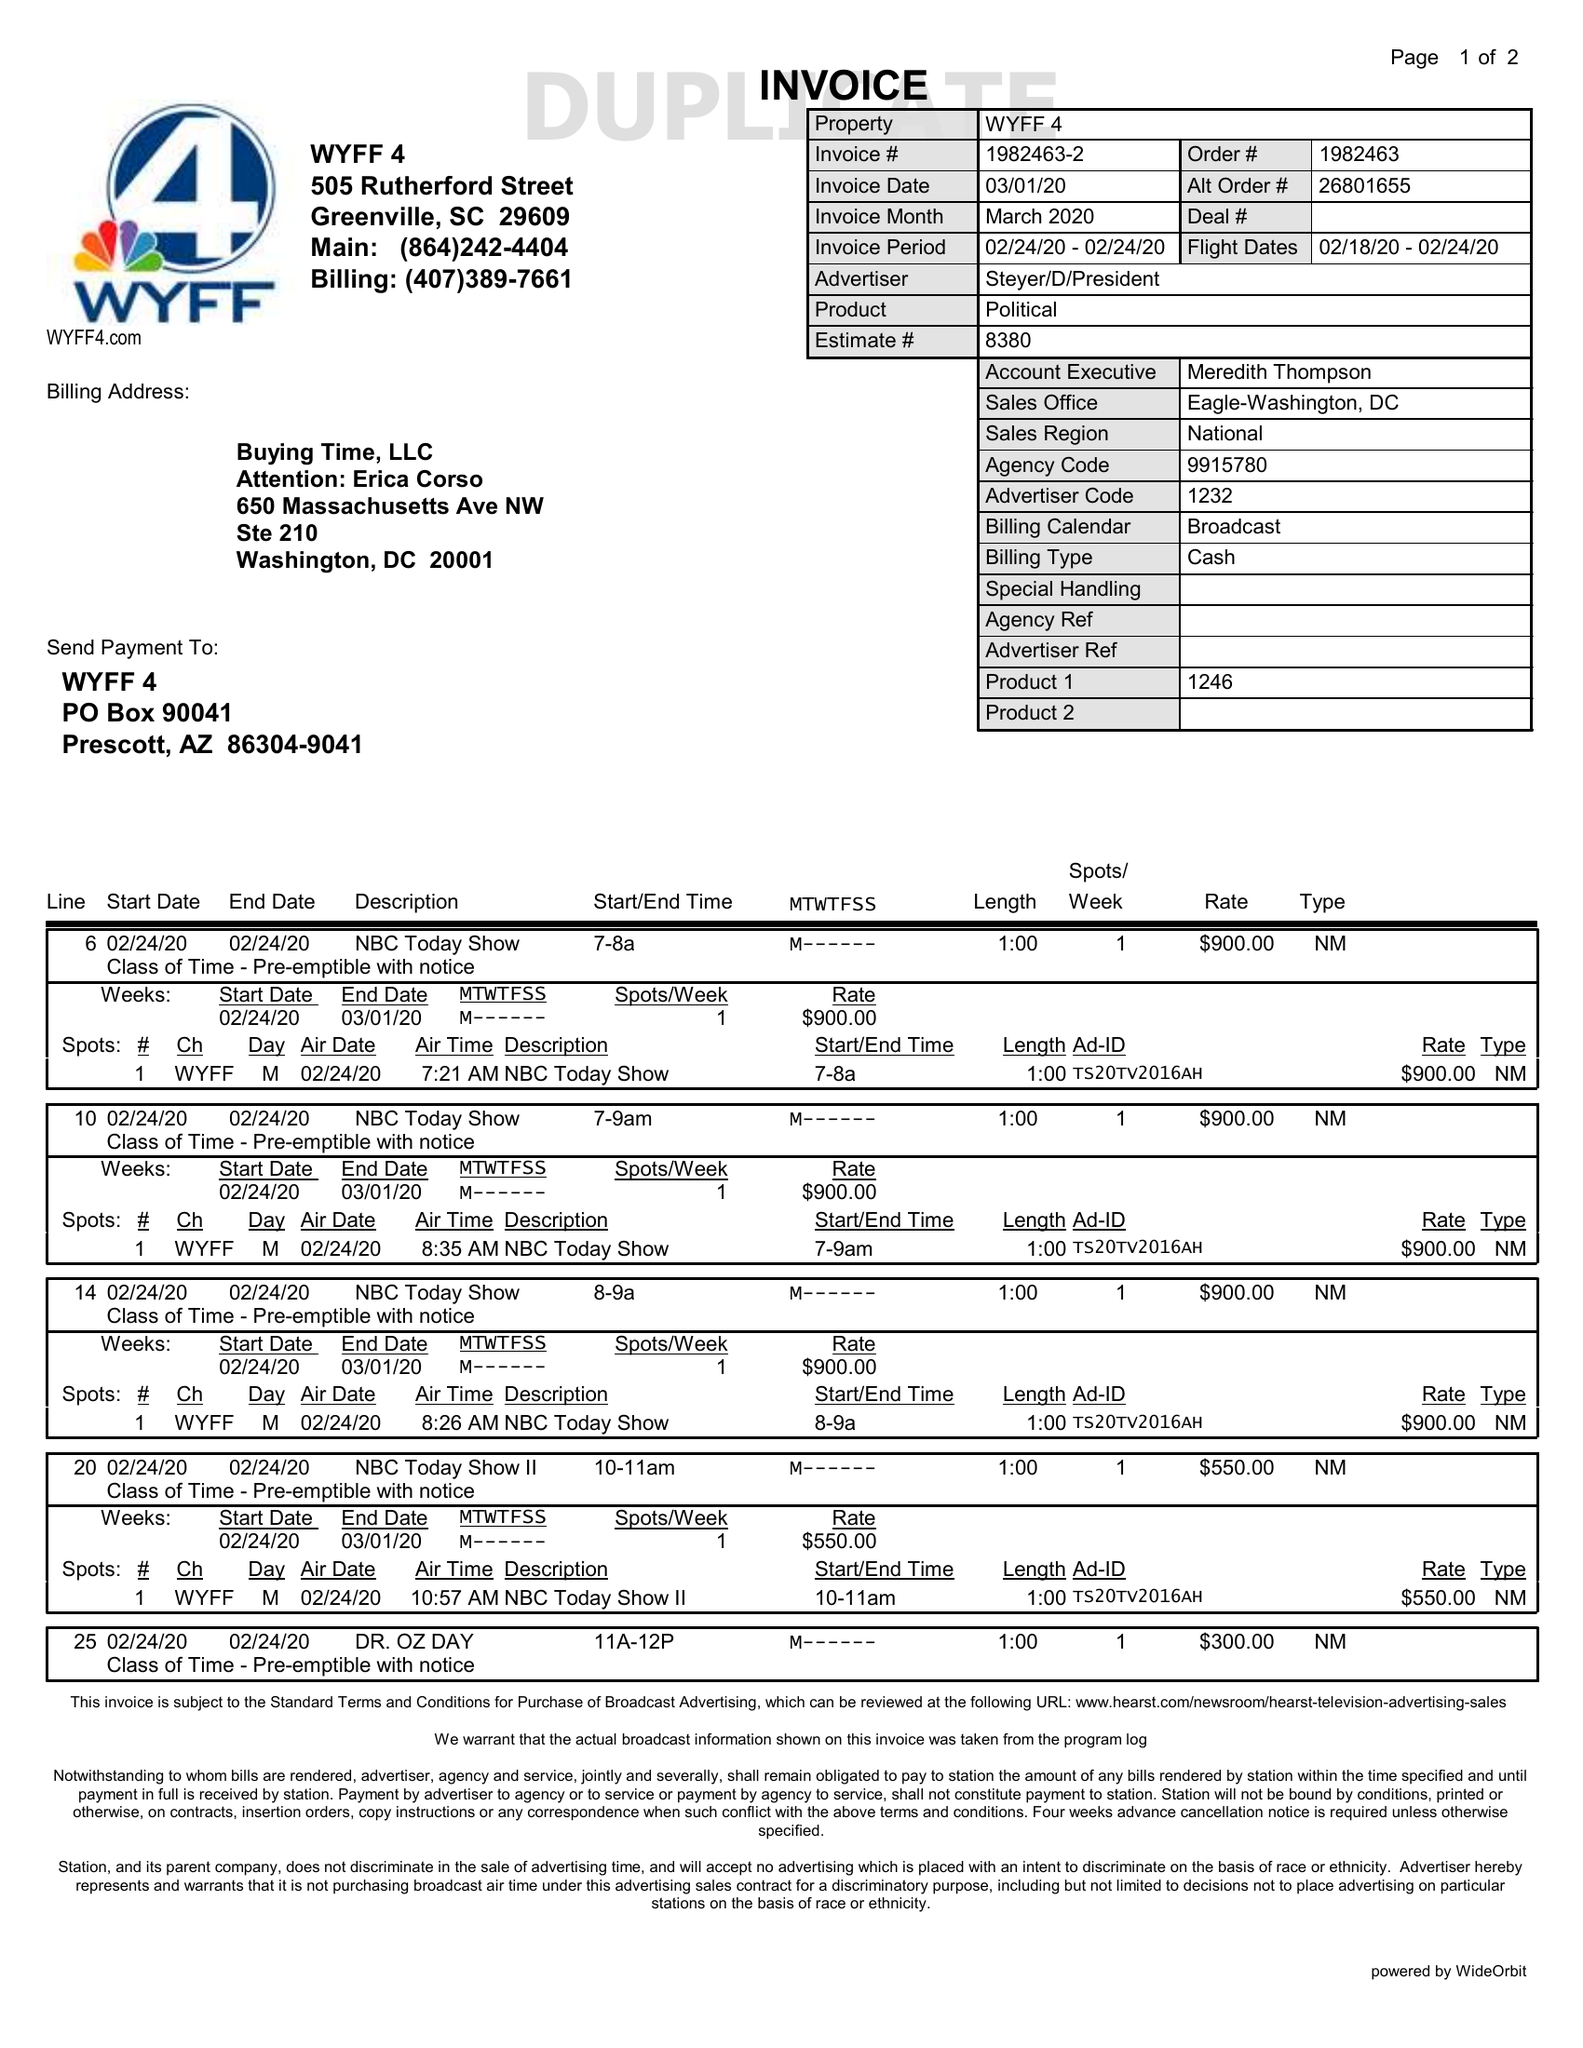What is the value for the advertiser?
Answer the question using a single word or phrase. STEYER/D/PRESIDENT 